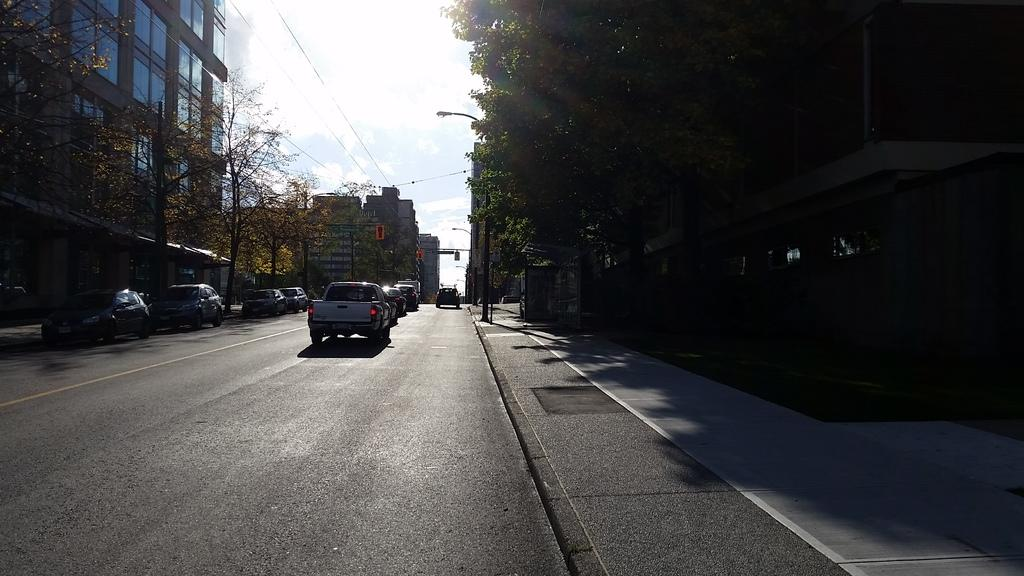What can be seen on the road in the image? There are vehicles on the road in the image. What is visible in the background of the image? In the background of the image, there are lights, trees, buildings, the sky, and other objects on the ground. Can you describe the setting of the image? The image shows a road with vehicles, surrounded by lights, trees, buildings, and the sky in the background. What type of potato is being used to select the nation in the image? There is no potato or nation mentioned in the image; it features vehicles on a road with lights, trees, buildings, and the sky in the background. 